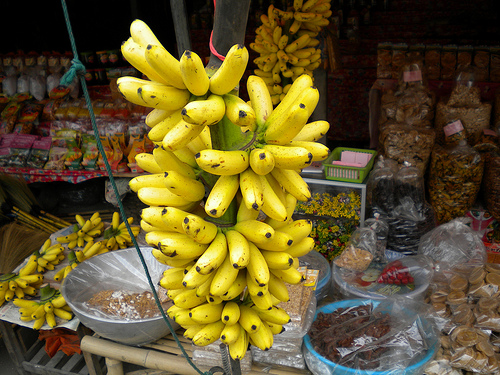Please provide the bounding box coordinate of the region this sentence describes: a round blue bowl. The bounding box coordinates for the round blue bowl are estimated to be [0.61, 0.72, 0.88, 0.87], suggesting the bowl is partially visible and may contain goods complimentary to the vibrant market atmosphere. 